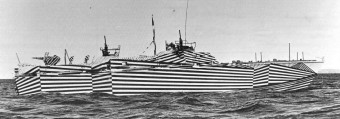How did sailors feel about serving on these visually distinctive ships? Sailors' reactions to serving on dazzle camouflage ships were mixed. Some took pride in the unique appearance and the innovative approach to defense, while others were skeptical about its effectiveness. Nonetheless, it became an integral part of naval history and is often remembered for its bold and artistic designs. 